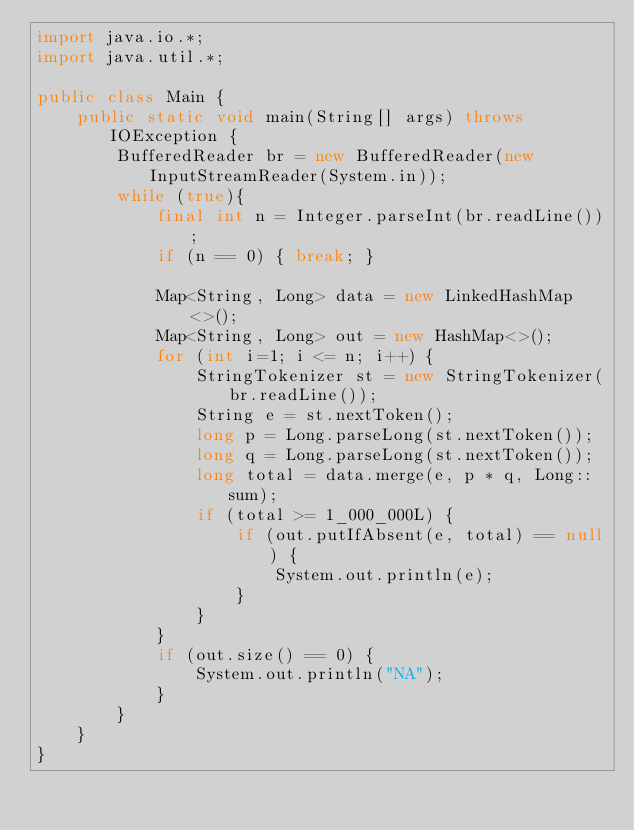<code> <loc_0><loc_0><loc_500><loc_500><_Java_>import java.io.*;
import java.util.*;

public class Main {
    public static void main(String[] args) throws IOException {
        BufferedReader br = new BufferedReader(new InputStreamReader(System.in));
        while (true){
            final int n = Integer.parseInt(br.readLine());
            if (n == 0) { break; }
            
            Map<String, Long> data = new LinkedHashMap<>();
            Map<String, Long> out = new HashMap<>();
            for (int i=1; i <= n; i++) {
                StringTokenizer st = new StringTokenizer(br.readLine());
                String e = st.nextToken();
                long p = Long.parseLong(st.nextToken());
                long q = Long.parseLong(st.nextToken());
                long total = data.merge(e, p * q, Long::sum);
                if (total >= 1_000_000L) {
                    if (out.putIfAbsent(e, total) == null) {
                        System.out.println(e);
                    }
                }
            }
            if (out.size() == 0) {
                System.out.println("NA");
            }
        }
    }
}</code> 